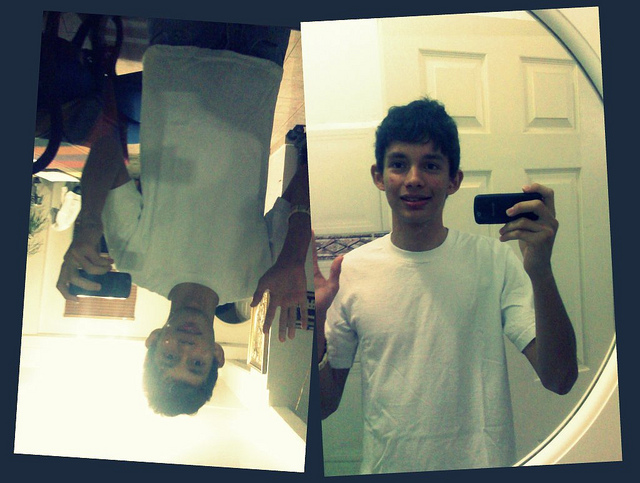Imagine if the door in the background led to a magical world. What would it look like? If the door in the background led to a magical world, stepping through it would reveal a vibrant landscape bathed in golden sunlight. Enormous, bioluminescent trees towered overhead, their leaves glittering with hues of blue and green. Rivers of sparkling water wound through the lush forest, home to fascinating creatures with wings of light and fur that shimmered like stardust. This enchanted land was a place where gravity behaved whimsically, allowing people to float gently above the ground with each step, and where the air was filled with the harmonious melodies of the flora and fauna. It was a realm of endless wonder and breathtaking beauty, a place where the boundaries of imagination and reality blurred into one. 